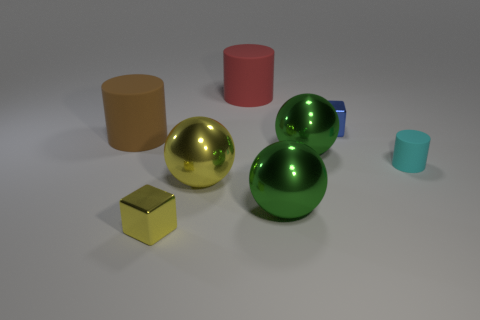The matte thing that is the same size as the blue metallic cube is what color?
Keep it short and to the point. Cyan. How many objects are large matte objects that are left of the small yellow metal object or objects right of the brown cylinder?
Offer a terse response. 8. What number of objects are cyan rubber objects or big brown matte balls?
Make the answer very short. 1. What size is the metal thing that is to the left of the red thing and behind the tiny yellow shiny object?
Offer a very short reply. Large. How many balls have the same material as the blue object?
Offer a very short reply. 3. What is the color of the other block that is the same material as the blue cube?
Your response must be concise. Yellow. Do the big cylinder on the right side of the yellow cube and the tiny rubber thing have the same color?
Your response must be concise. No. There is a small block that is in front of the small blue thing; what is its material?
Your answer should be very brief. Metal. Are there the same number of tiny cyan rubber cylinders to the left of the yellow ball and brown matte cylinders?
Your answer should be very brief. No. What number of other things are the same color as the small rubber thing?
Your response must be concise. 0. 